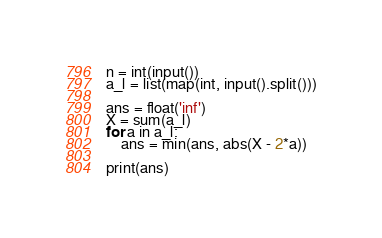<code> <loc_0><loc_0><loc_500><loc_500><_Python_>n = int(input())
a_l = list(map(int, input().split()))

ans = float('inf')
X = sum(a_l)
for a in a_l:
    ans = min(ans, abs(X - 2*a))

print(ans)</code> 